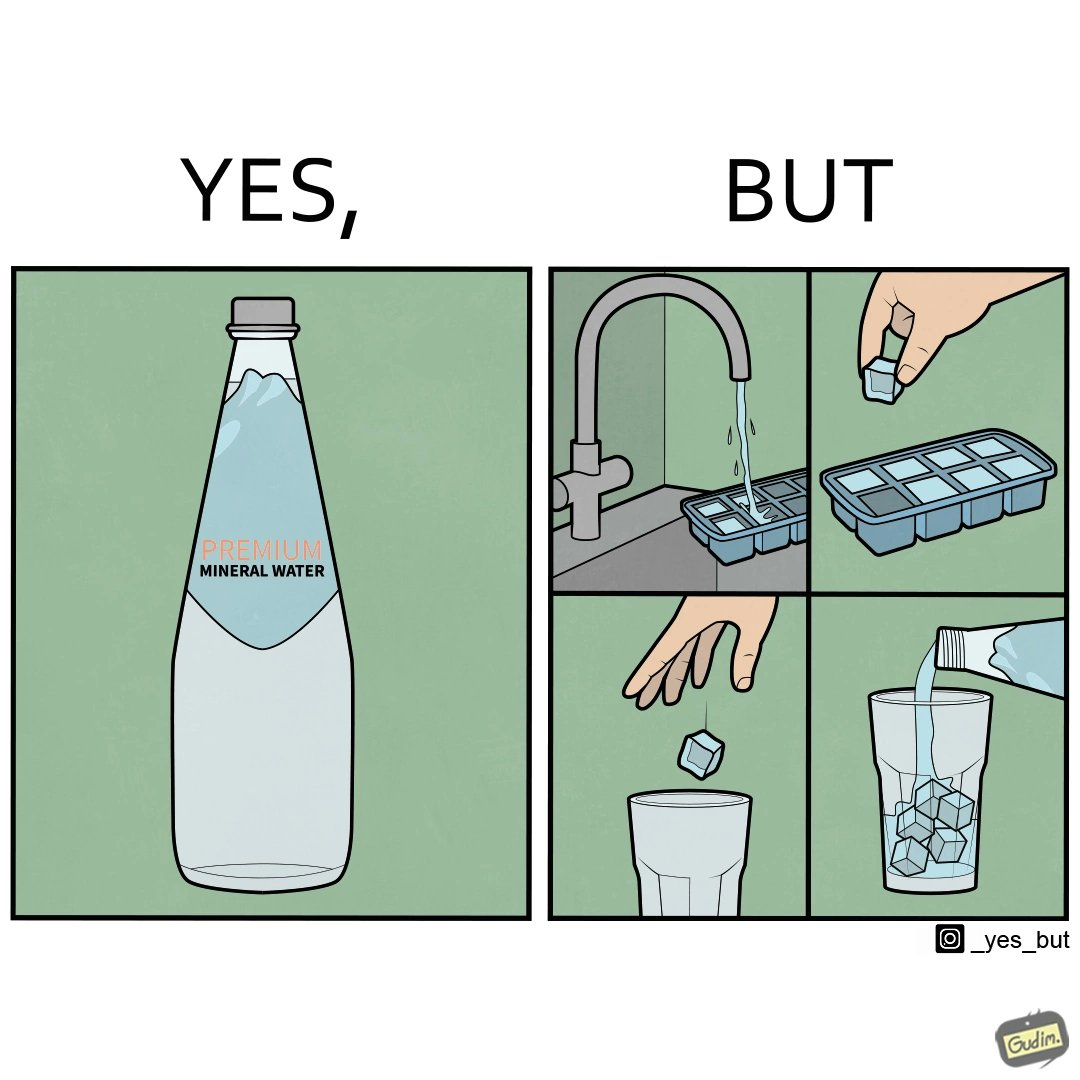Is this image satirical or non-satirical? Yes, this image is satirical. 